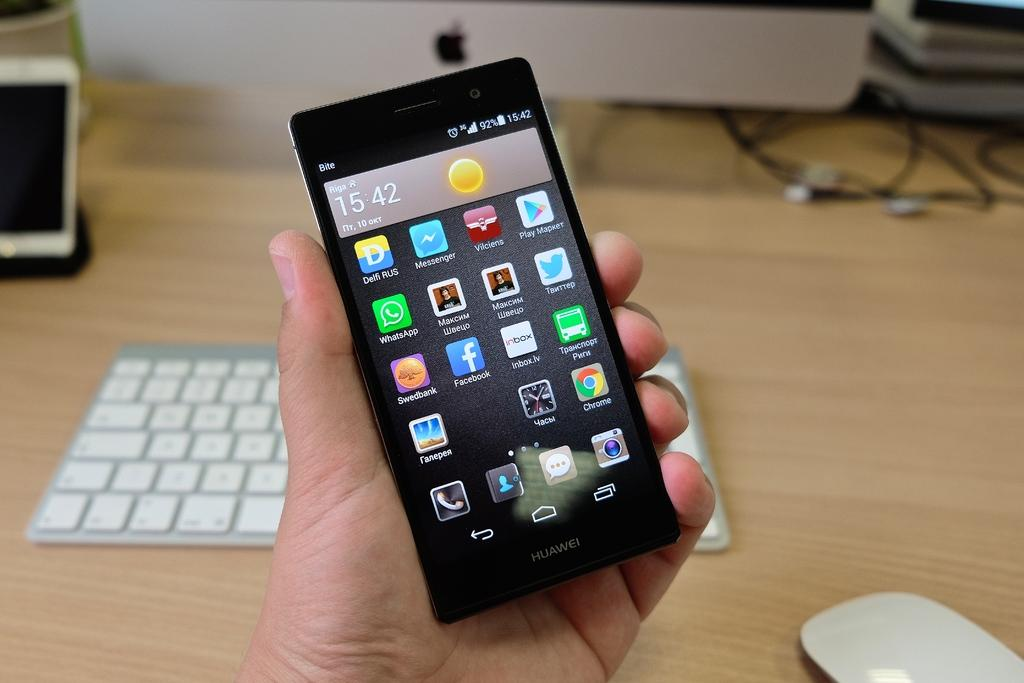What is the human hand holding in the image? The human hand is holding a mobile in the image. What type of device is visible in the image? There is a keyboard and a monitor present in the image. What is the purpose of the mouse in the image? The mouse is used for controlling the computer, which is indicated by the presence of the keyboard and monitor. Are there any other mobiles in the image? Yes, there is another mobile on the side in the image. What color is the cow's hair in the image? There is no cow or hair present in the image. What impulse is the human hand experiencing in the image? There is no indication of any impulses experienced by the human hand in the image. 